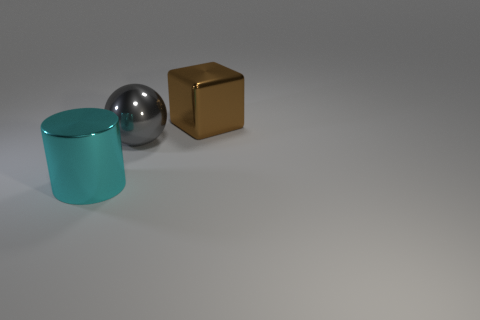Add 1 big cyan cylinders. How many objects exist? 4 Subtract all spheres. How many objects are left? 2 Subtract 1 cubes. How many cubes are left? 0 Subtract all big brown spheres. Subtract all brown shiny cubes. How many objects are left? 2 Add 1 big gray shiny objects. How many big gray shiny objects are left? 2 Add 3 big red metallic things. How many big red metallic things exist? 3 Subtract 0 green blocks. How many objects are left? 3 Subtract all brown balls. Subtract all purple cylinders. How many balls are left? 1 